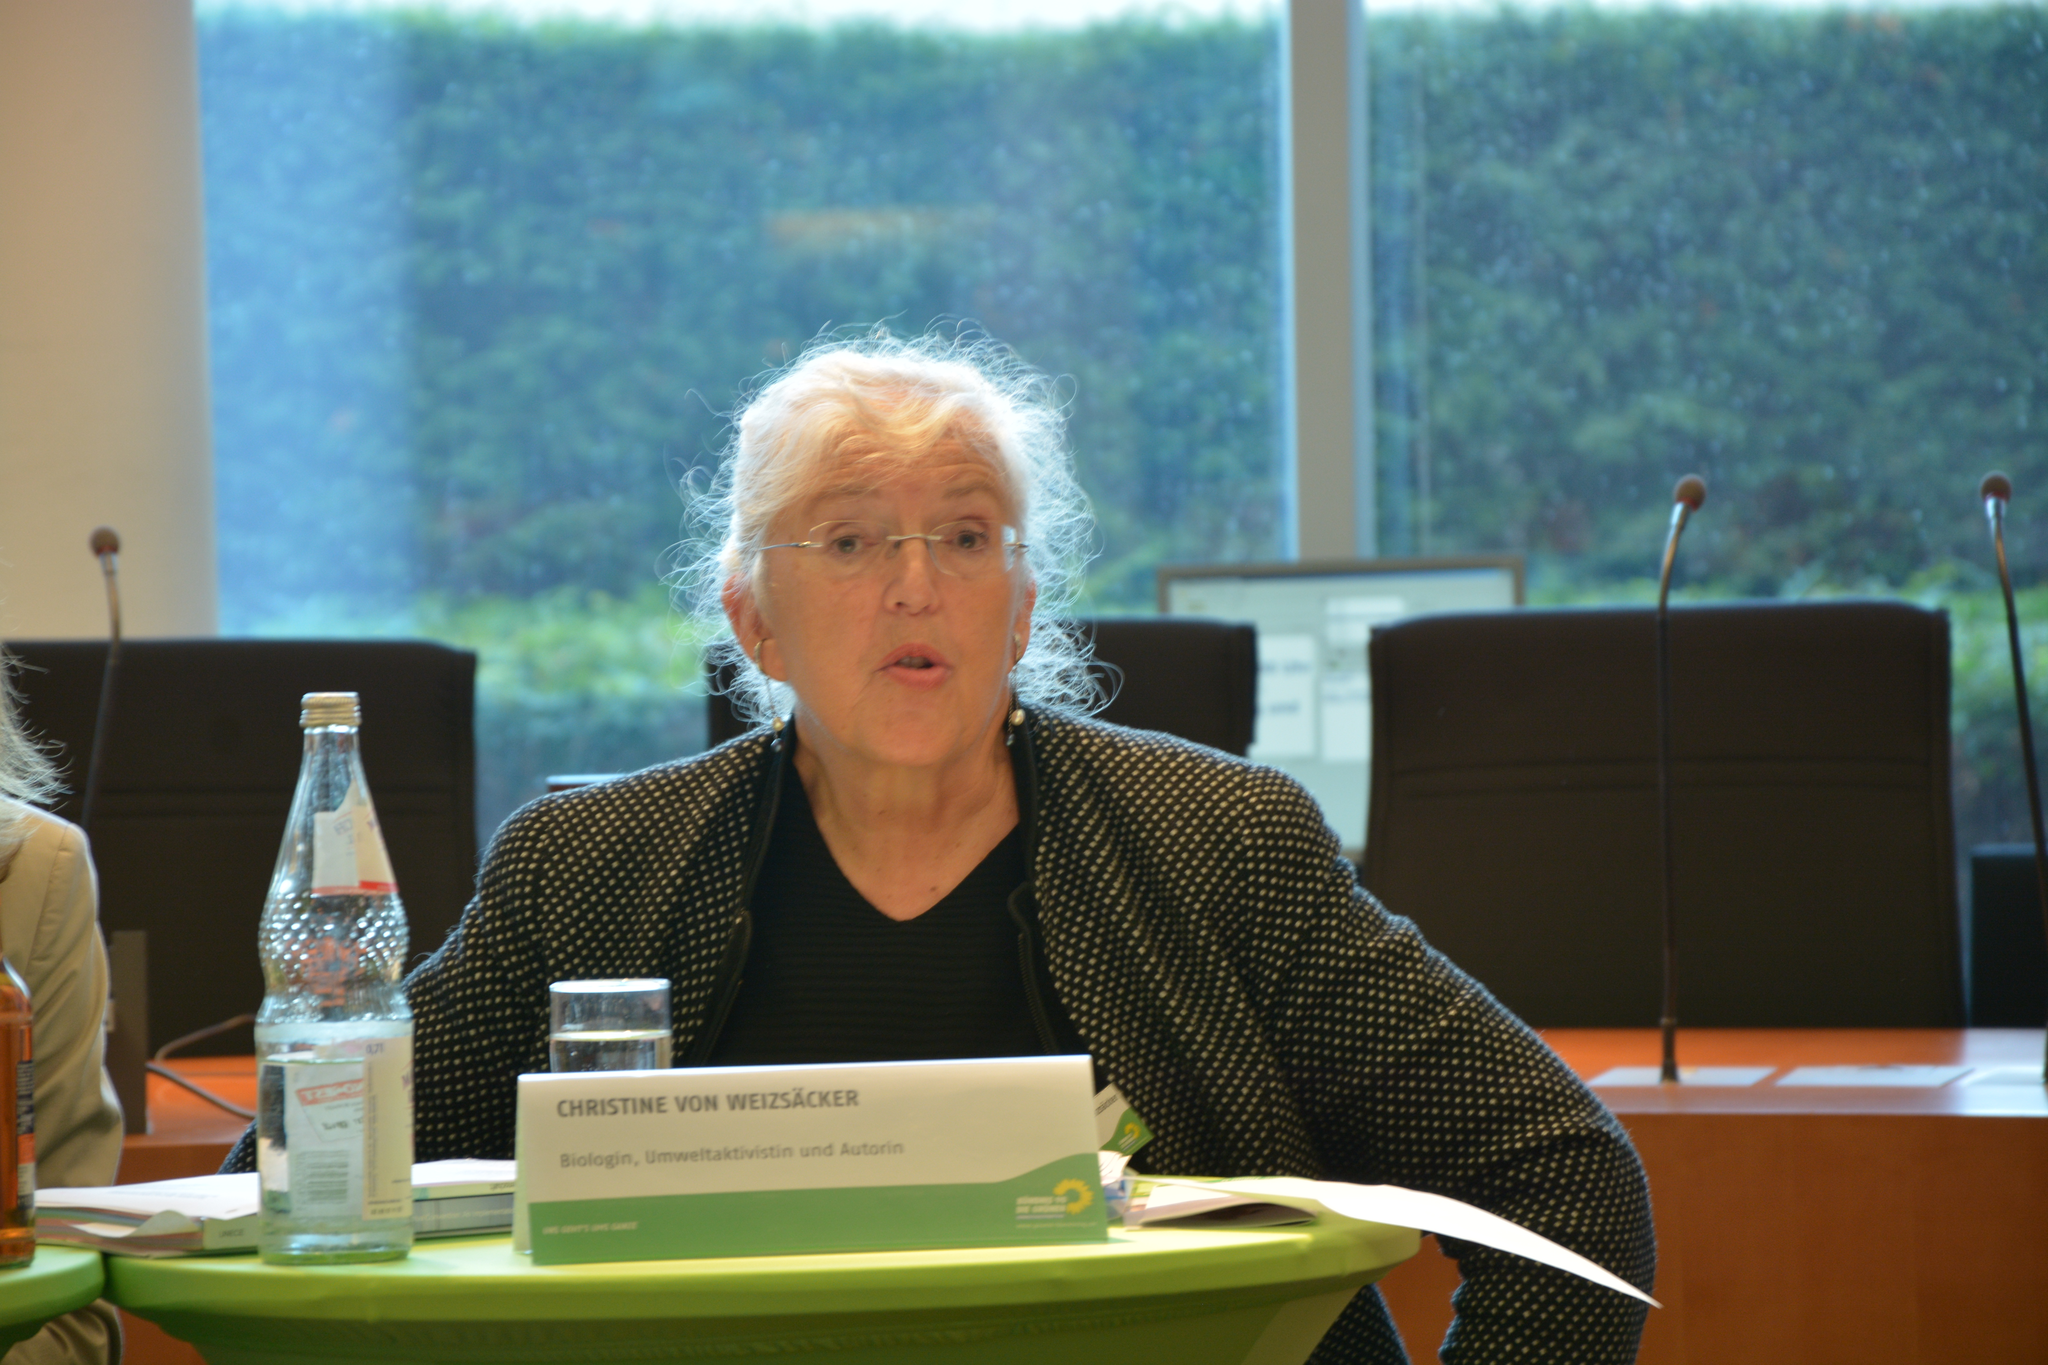<image>
Present a compact description of the photo's key features. a woman standing behind a small sign that says 'christine von weizsacker' 